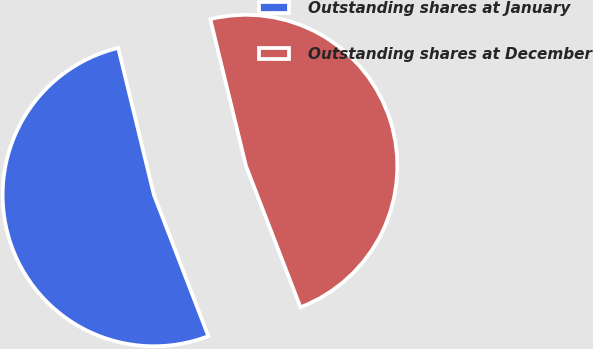Convert chart to OTSL. <chart><loc_0><loc_0><loc_500><loc_500><pie_chart><fcel>Outstanding shares at January<fcel>Outstanding shares at December<nl><fcel>52.06%<fcel>47.94%<nl></chart> 